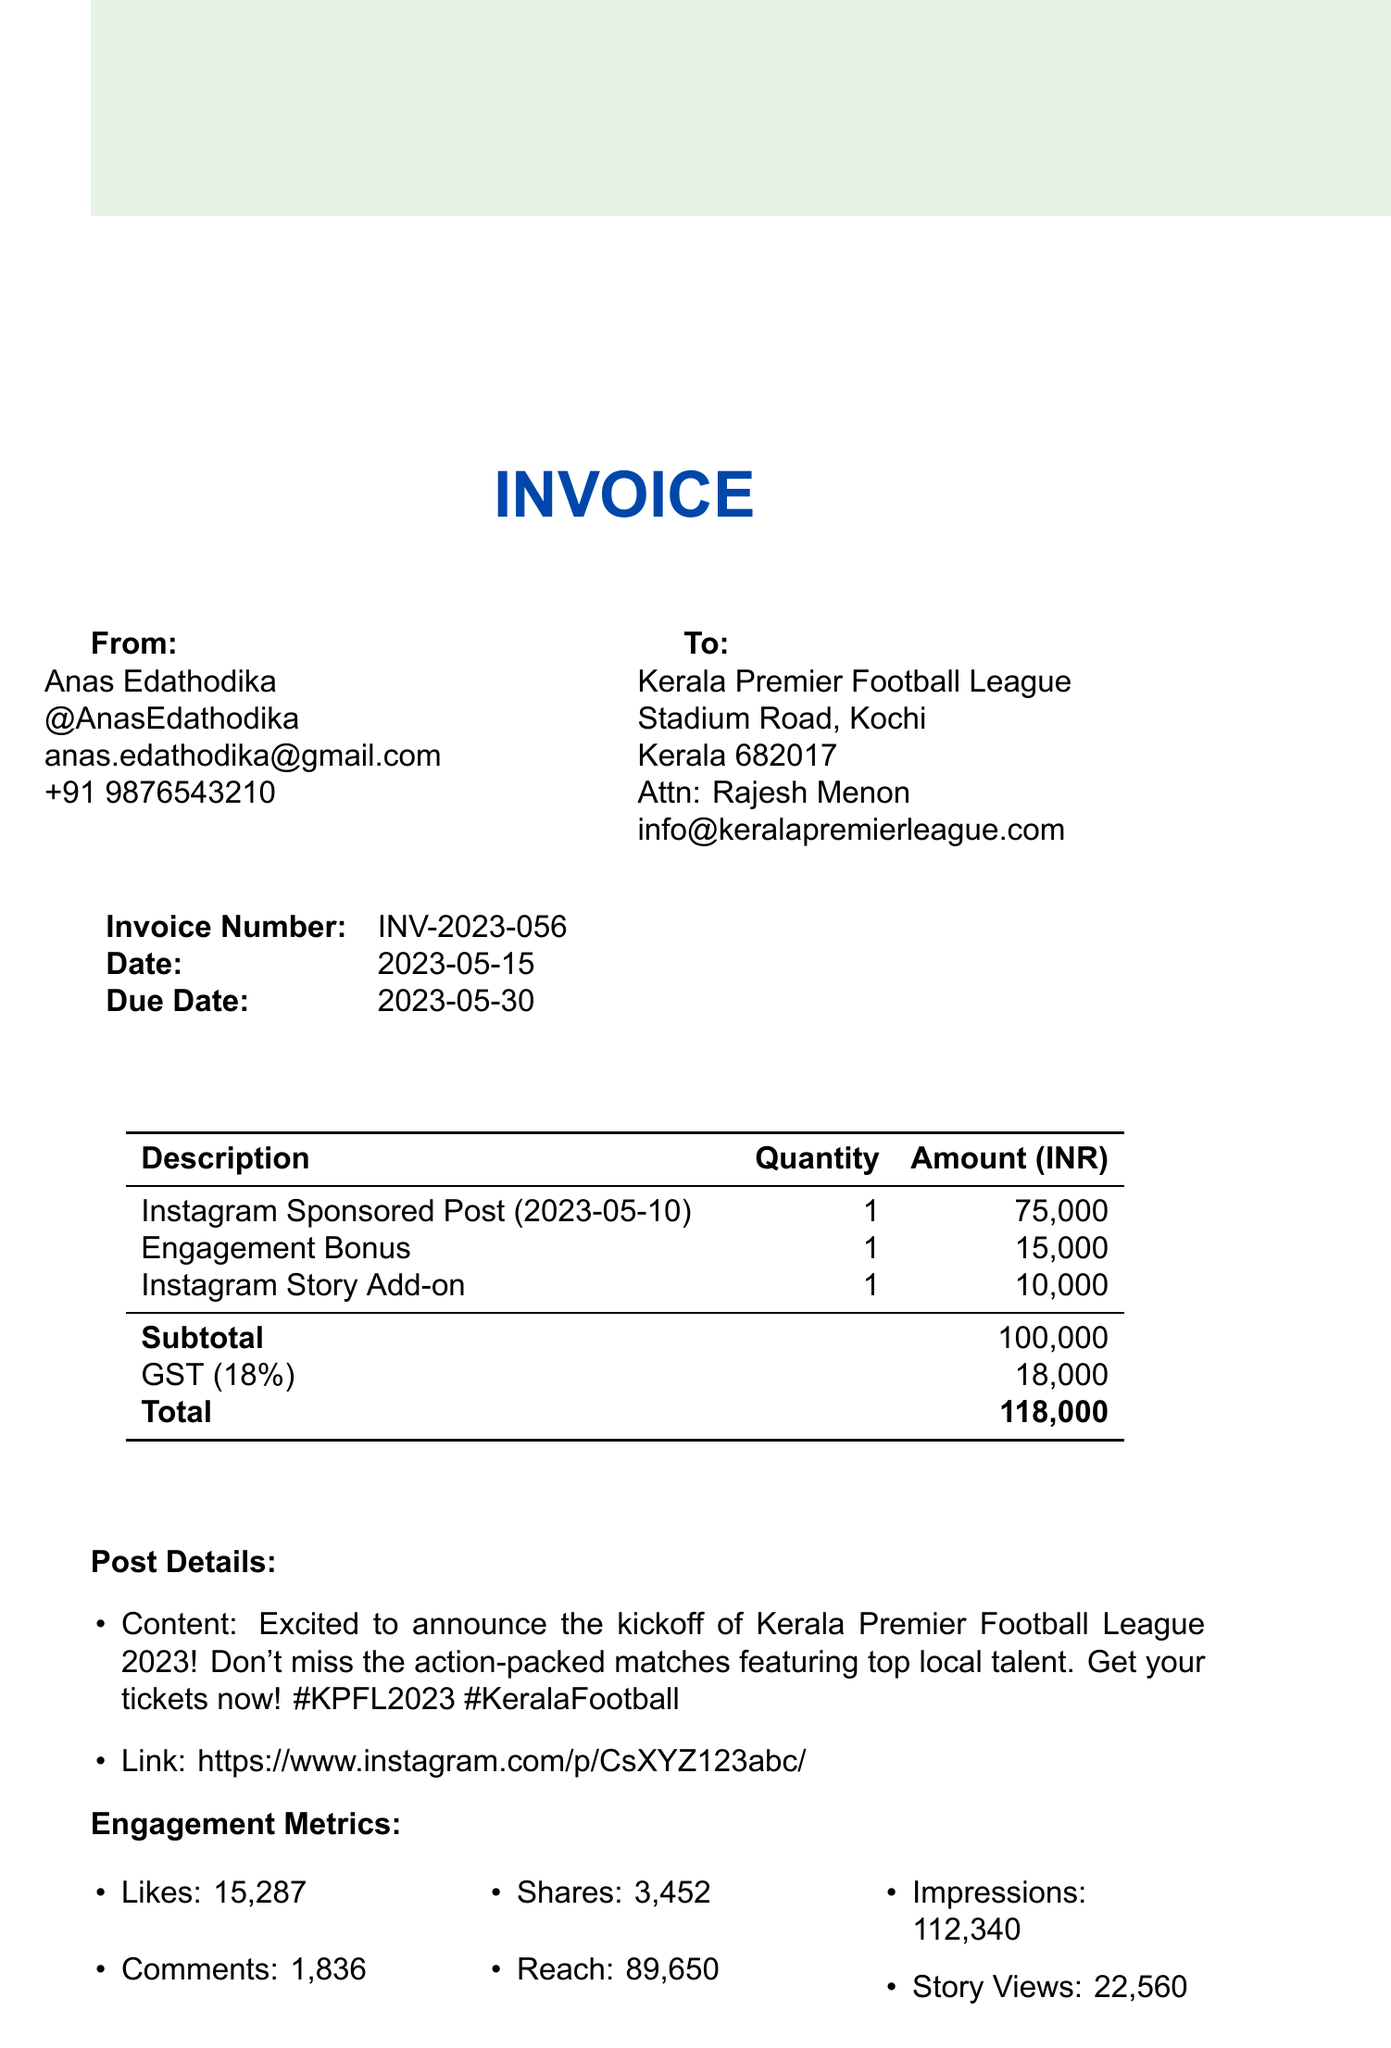What is the invoice number? The invoice number is a unique identifier for the invoice, recorded in the document as INV-2023-056.
Answer: INV-2023-056 Who is the contact person for the client? The contact person for Kerala Premier Football League is mentioned in the document as Rajesh Menon.
Answer: Rajesh Menon What is the total amount due? The total amount due includes the subtotal and the GST, resulting in a total of 118,000.
Answer: 118,000 On what date was the sponsored post made? The post date is specified in the document as May 10, 2023.
Answer: May 10, 2023 How many likes did the post receive? The document states that the post received 15,287 likes, which is an engagement metric for the sponsored post.
Answer: 15,287 What is the GST percentage applied in this invoice? The invoice mentions the GST as 18%, which is calculated on the subtotal amount.
Answer: 18% What is the base rate for the sponsored post? The base rate is detailed in the pricing section of the document as 75,000.
Answer: 75,000 What is the due date for payment? The due date for making the payment is noted as May 30, 2023, in the document.
Answer: May 30, 2023 What bank is listed for payment? The document provides Federal Bank as the bank where the payment should be made.
Answer: Federal Bank 